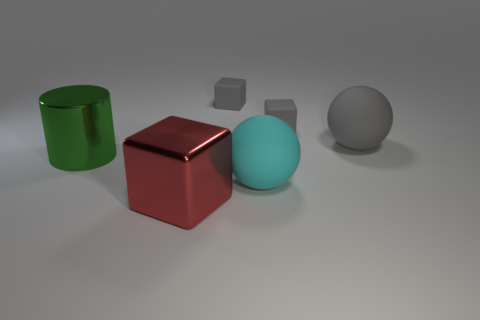There is a rubber cube right of the cyan rubber thing; what size is it?
Ensure brevity in your answer.  Small. There is another big matte thing that is the same shape as the large gray thing; what is its color?
Your answer should be very brief. Cyan. The cube that is the same material as the green thing is what color?
Your response must be concise. Red. How many red spheres are made of the same material as the cyan thing?
Offer a terse response. 0. There is a large matte ball that is in front of the shiny cylinder that is to the left of the big gray sphere; what is its color?
Your answer should be compact. Cyan. What is the color of the other ball that is the same size as the cyan ball?
Your answer should be very brief. Gray. Is there another matte object that has the same shape as the cyan thing?
Ensure brevity in your answer.  Yes. What is the shape of the big green object?
Make the answer very short. Cylinder. Are there more big metallic things that are right of the big green object than large spheres left of the cyan matte sphere?
Your answer should be very brief. Yes. What number of other things are there of the same size as the cylinder?
Offer a very short reply. 3. 